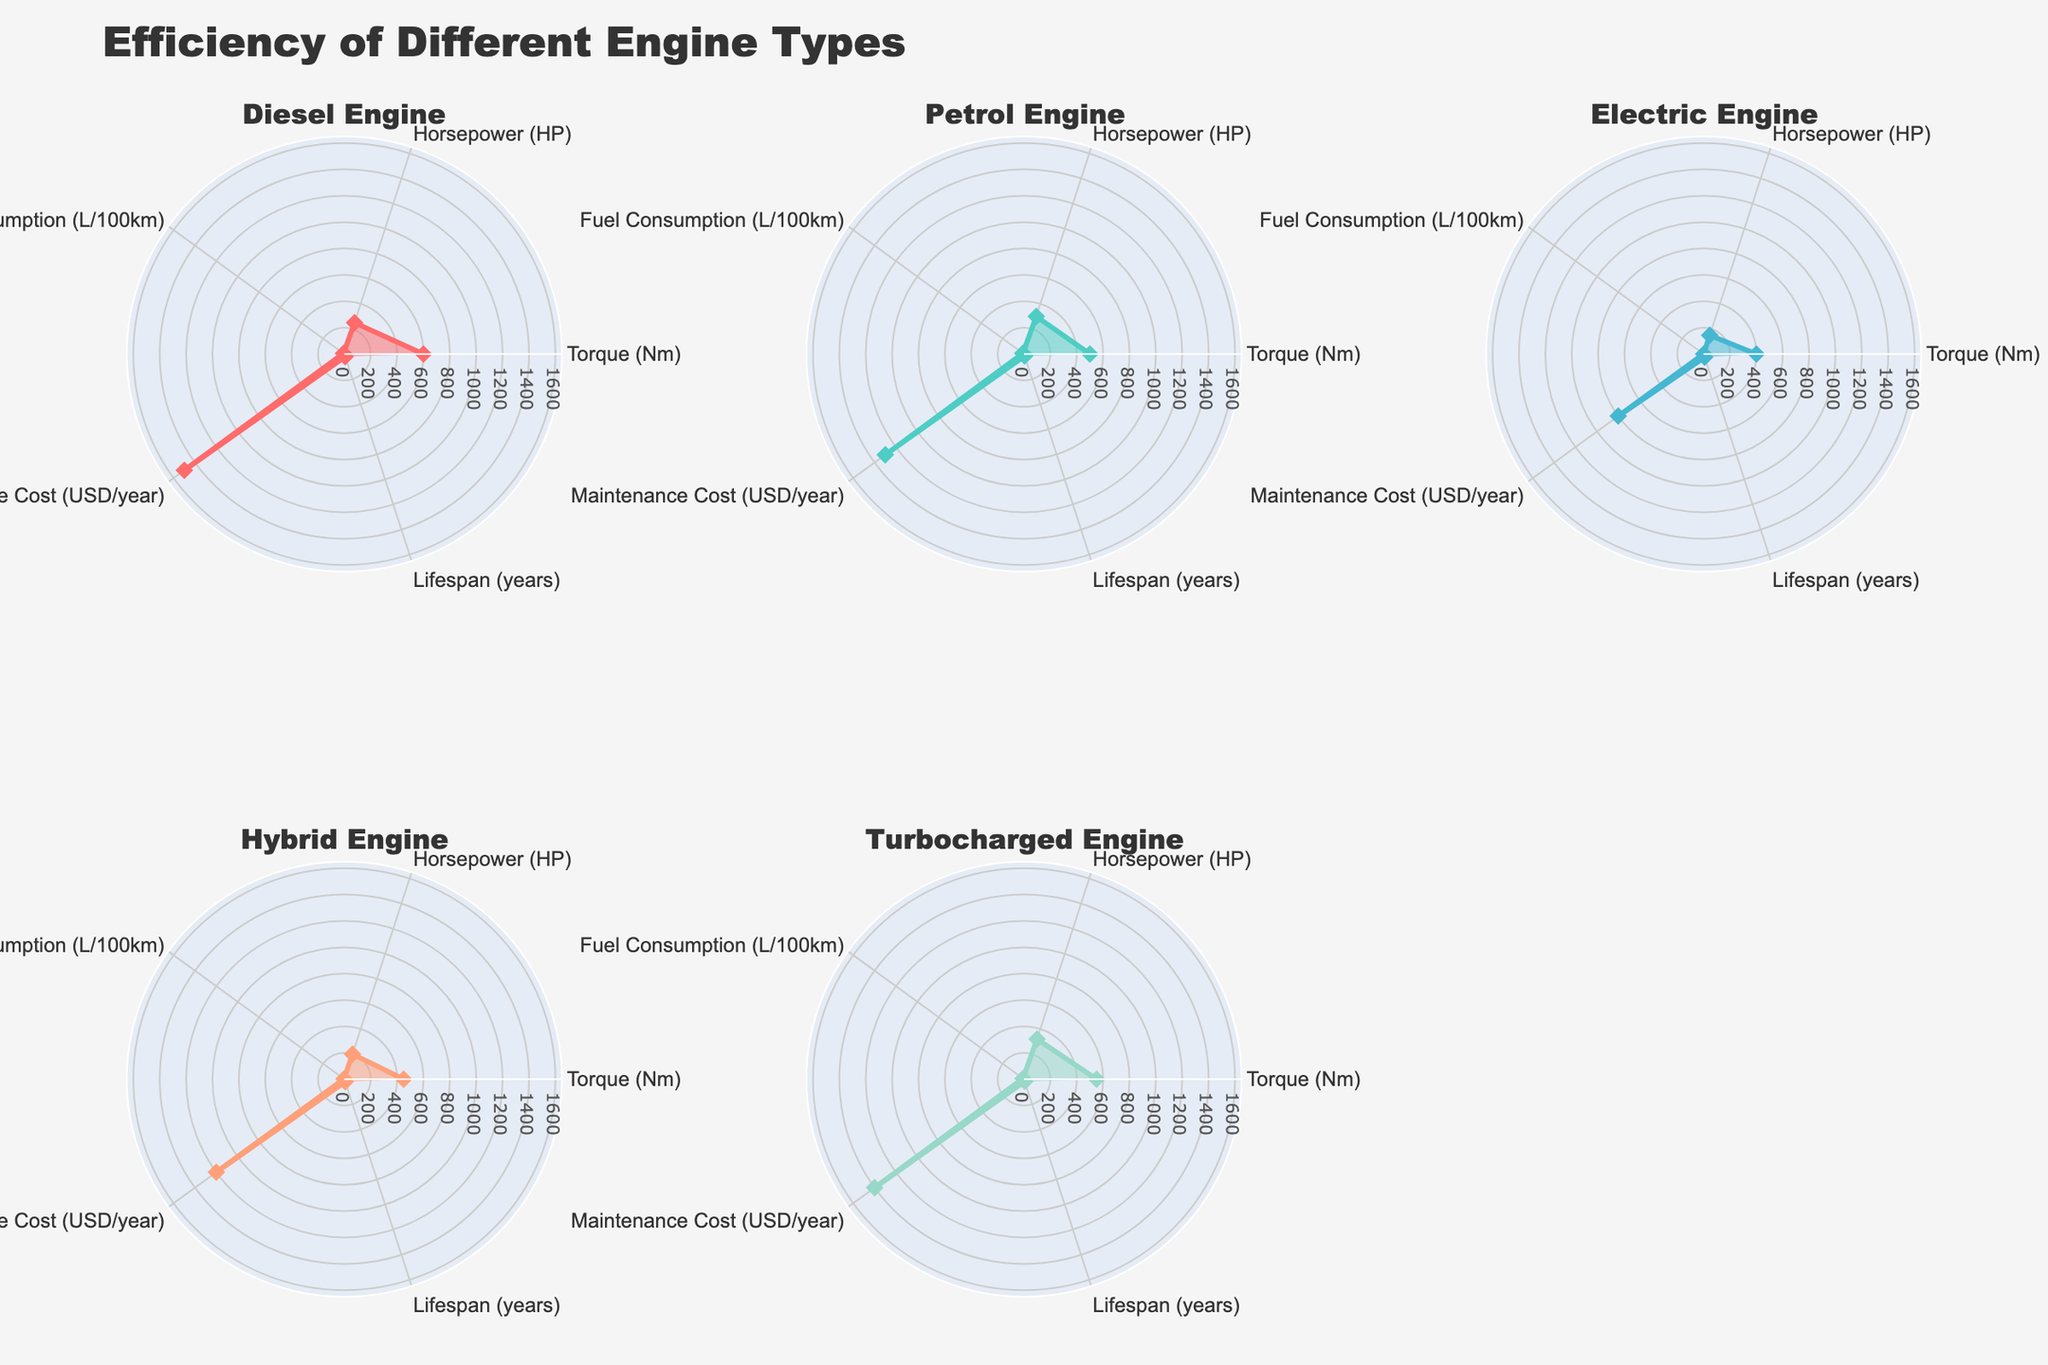Which engine type has the highest torque? The highest torque value is represented by the Diesel Engine, which shows 600 Nm on the graph.
Answer: Diesel Engine What is the general trend for maintenance cost among the engines? The maintenance costs are highest for Diesel Engine and lowest for Electric Engine, petrol and turbocharged engines have moderate costs.
Answer: Diesel > Turbocharged > Diesel > Hybrid > Electric How much more horsepower does the Turbocharged Engine have compared to the Electric Engine? Subtract the horsepower value for Electric Engine (150 HP) from the Turbocharged Engine (320 HP), resulting in 320 - 150 = 170 HP.
Answer: 170 HP Which engine type has the best lifespan? The Electric Engine has the longest lifespan, showing 25 years on the graph.
Answer: Electric Engine Which engine has the lowest fuel consumption? The Electric Engine shows the lowest fuel consumption with 0 L/100km.
Answer: Electric Engine What is the difference in maintenance costs between the Petrol Engine and the Hybrid Engine? Subtract the maintenance cost of Hybrid Engine (1200 USD/year) from Petrol Engine (1300 USD/year), resulting in 1300 - 1200 = 100 USD/year.
Answer: 100 USD/year Which two engine types have the same lifespan? The Diesel Engine and Hybrid Engine both show a lifespan of 20 years on the graph.
Answer: Diesel Engine and Hybrid Engine Compare the torque of the Petrol Engine and the Hybrid Engine. Which one is greater and by how much? The torque of the Petrol Engine is 500 Nm, and the Hybrid Engine is 450 Nm. The difference is 500 - 450 = 50 Nm.
Answer: Petrol Engine by 50 Nm Rank the engines in order of increasing horsepower. The engines in increasing horsepower are: Electric Engine (150 HP), Hybrid Engine (200 HP), Diesel Engine (250 HP), Petrol Engine (300 HP), Turbocharged Engine (320 HP).
Answer: Electric < Hybrid < Diesel < Petrol < Turbocharged What is the average lifespan of all the engine types? Sum the lifespan of all engines (20+15+25+20+18) and divide by 5, resulting in (20+15+25+20+18) / 5 = 19.6 years.
Answer: 19.6 years 